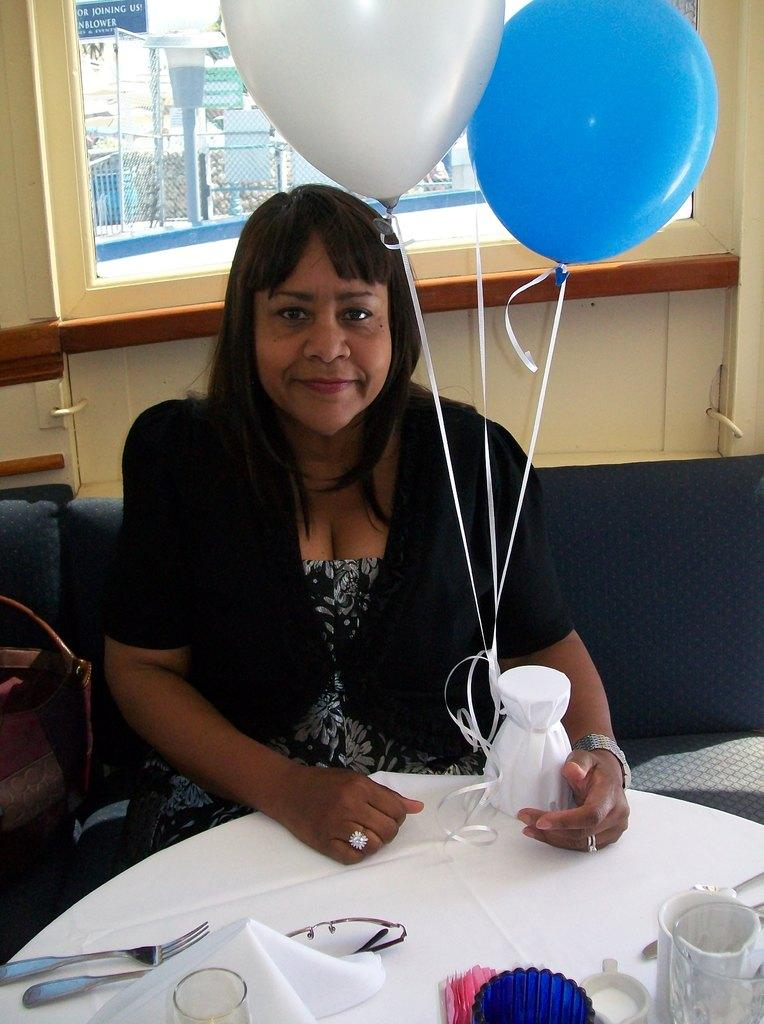What is the woman doing in the image? The woman is sitting in front of a table. What objects are on the table? There are forks, a glass, and tissues on the table. What is the woman holding in the image? The woman is holding two balloons. What type of fan is being used to cool the woman down in the image? There is no fan present in the image. What type of sail is visible in the background of the image? There is no sail present in the image. 